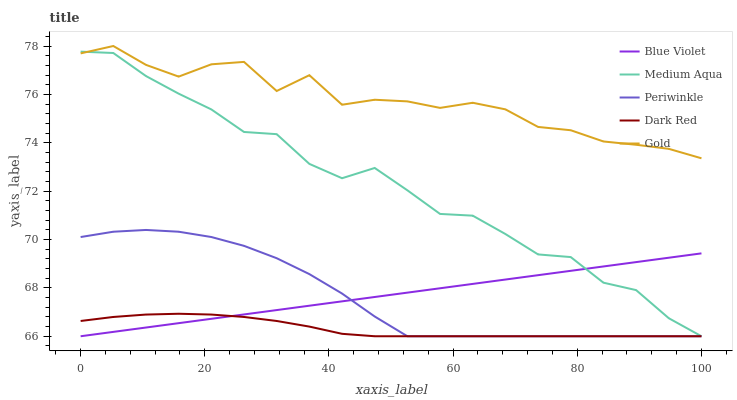Does Dark Red have the minimum area under the curve?
Answer yes or no. Yes. Does Gold have the maximum area under the curve?
Answer yes or no. Yes. Does Medium Aqua have the minimum area under the curve?
Answer yes or no. No. Does Medium Aqua have the maximum area under the curve?
Answer yes or no. No. Is Blue Violet the smoothest?
Answer yes or no. Yes. Is Gold the roughest?
Answer yes or no. Yes. Is Medium Aqua the smoothest?
Answer yes or no. No. Is Medium Aqua the roughest?
Answer yes or no. No. Does Periwinkle have the lowest value?
Answer yes or no. Yes. Does Gold have the lowest value?
Answer yes or no. No. Does Gold have the highest value?
Answer yes or no. Yes. Does Medium Aqua have the highest value?
Answer yes or no. No. Is Blue Violet less than Gold?
Answer yes or no. Yes. Is Gold greater than Dark Red?
Answer yes or no. Yes. Does Dark Red intersect Blue Violet?
Answer yes or no. Yes. Is Dark Red less than Blue Violet?
Answer yes or no. No. Is Dark Red greater than Blue Violet?
Answer yes or no. No. Does Blue Violet intersect Gold?
Answer yes or no. No. 